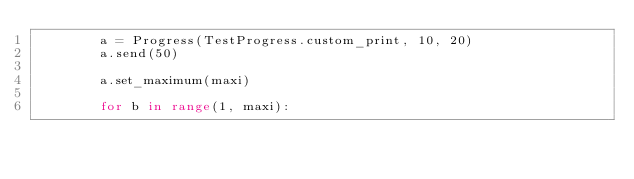<code> <loc_0><loc_0><loc_500><loc_500><_Python_>        a = Progress(TestProgress.custom_print, 10, 20)
        a.send(50)

        a.set_maximum(maxi)

        for b in range(1, maxi):</code> 